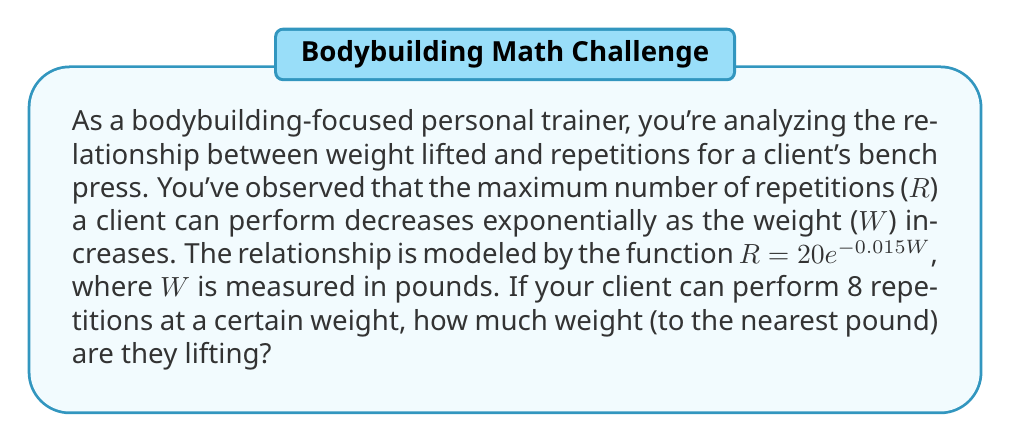Solve this math problem. To solve this problem, we'll use the given exponential function and the information about the client's performance. Let's approach this step-by-step:

1) The given function is $R = 20e^{-0.015W}$, where:
   R = number of repetitions
   W = weight in pounds

2) We're told that the client can perform 8 repetitions at a certain weight. So, we'll substitute R = 8 into our equation:

   $8 = 20e^{-0.015W}$

3) Now, we need to solve this equation for W. First, let's divide both sides by 20:

   $\frac{8}{20} = e^{-0.015W}$
   $0.4 = e^{-0.015W}$

4) To isolate W, we need to take the natural logarithm of both sides:

   $\ln(0.4) = \ln(e^{-0.015W})$

5) The natural log and e cancel on the right side:

   $\ln(0.4) = -0.015W$

6) Now we can solve for W by dividing both sides by -0.015:

   $W = \frac{\ln(0.4)}{-0.015}$

7) Let's calculate this:
   $W = \frac{-0.916290731}{-0.015} \approx 61.086$ pounds

8) Rounding to the nearest pound:
   W ≈ 61 pounds
Answer: The client is lifting approximately 61 pounds. 